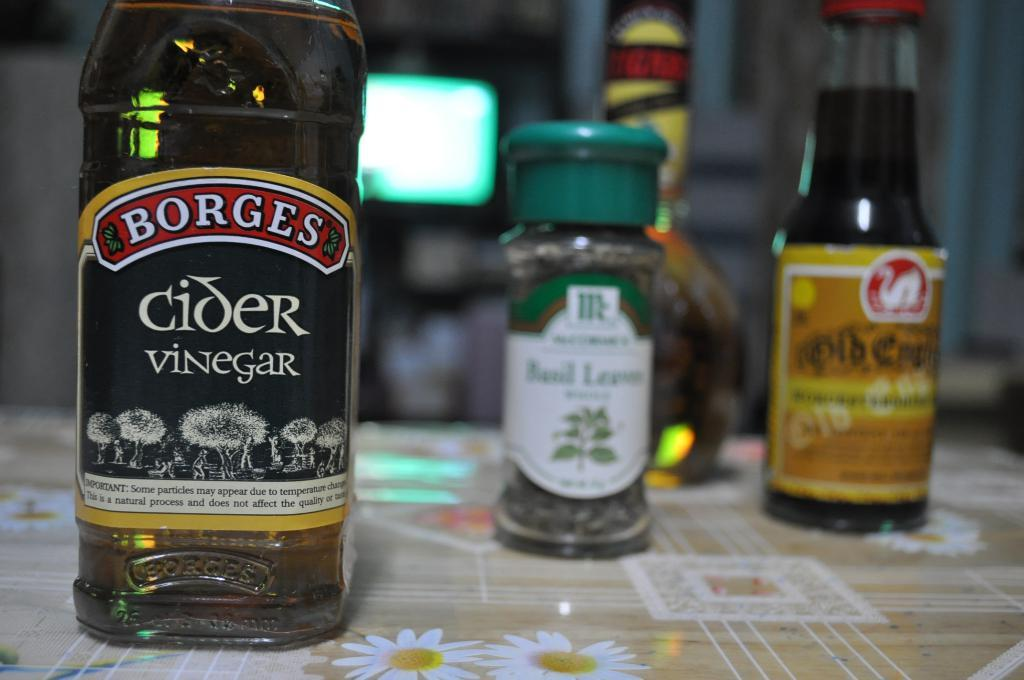What is on the table in the image? There is a glass bottle on a table in the image. What is written on the bottle? The bottle has "Borges Cider Vinegar" written on it. How many more bottles are visible in the image? There are three more bottles behind the first bottle. What type of light can be seen in the background of the image? There is a green light at the back of the scene. What type of bait is being used by the governor in the image? There is no governor or bait present in the image; it features a glass bottle with "Borges Cider Vinegar" written on it, along with three more bottles and a green light in the background. 